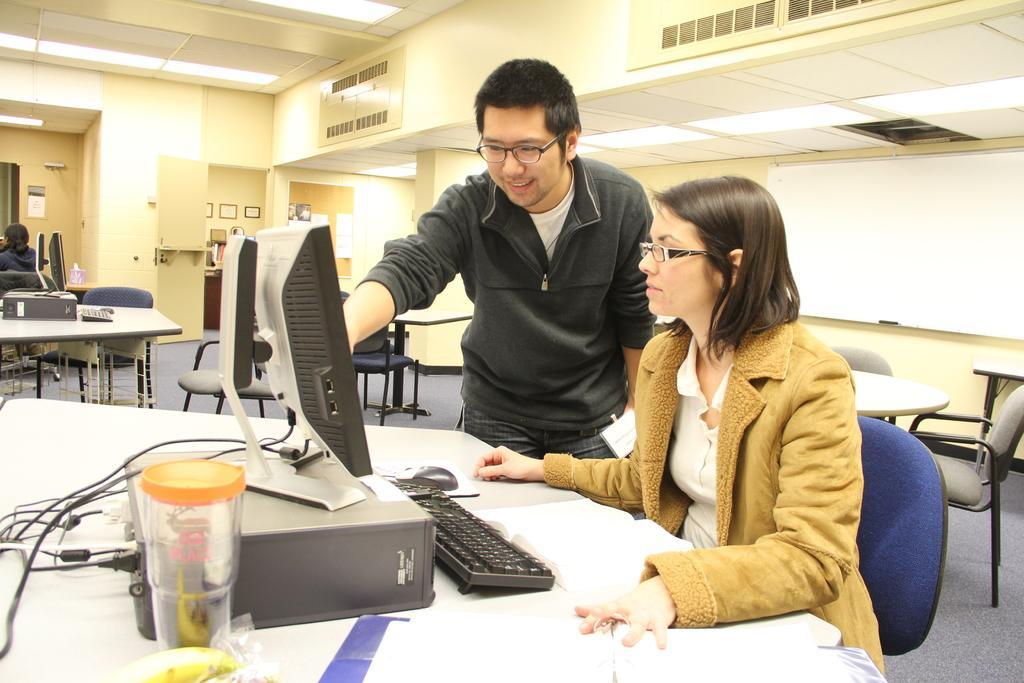Please provide a concise description of this image. Here in the front we can see a woman sitting on a chair and beside her we can see a man standing and in front of them we can see a monitor,a keyboard and a mouse and a CPU present on the table in front of them and there is also a bottle present on the table and beside them we can see same tables and chairs present and there are lights at the top 